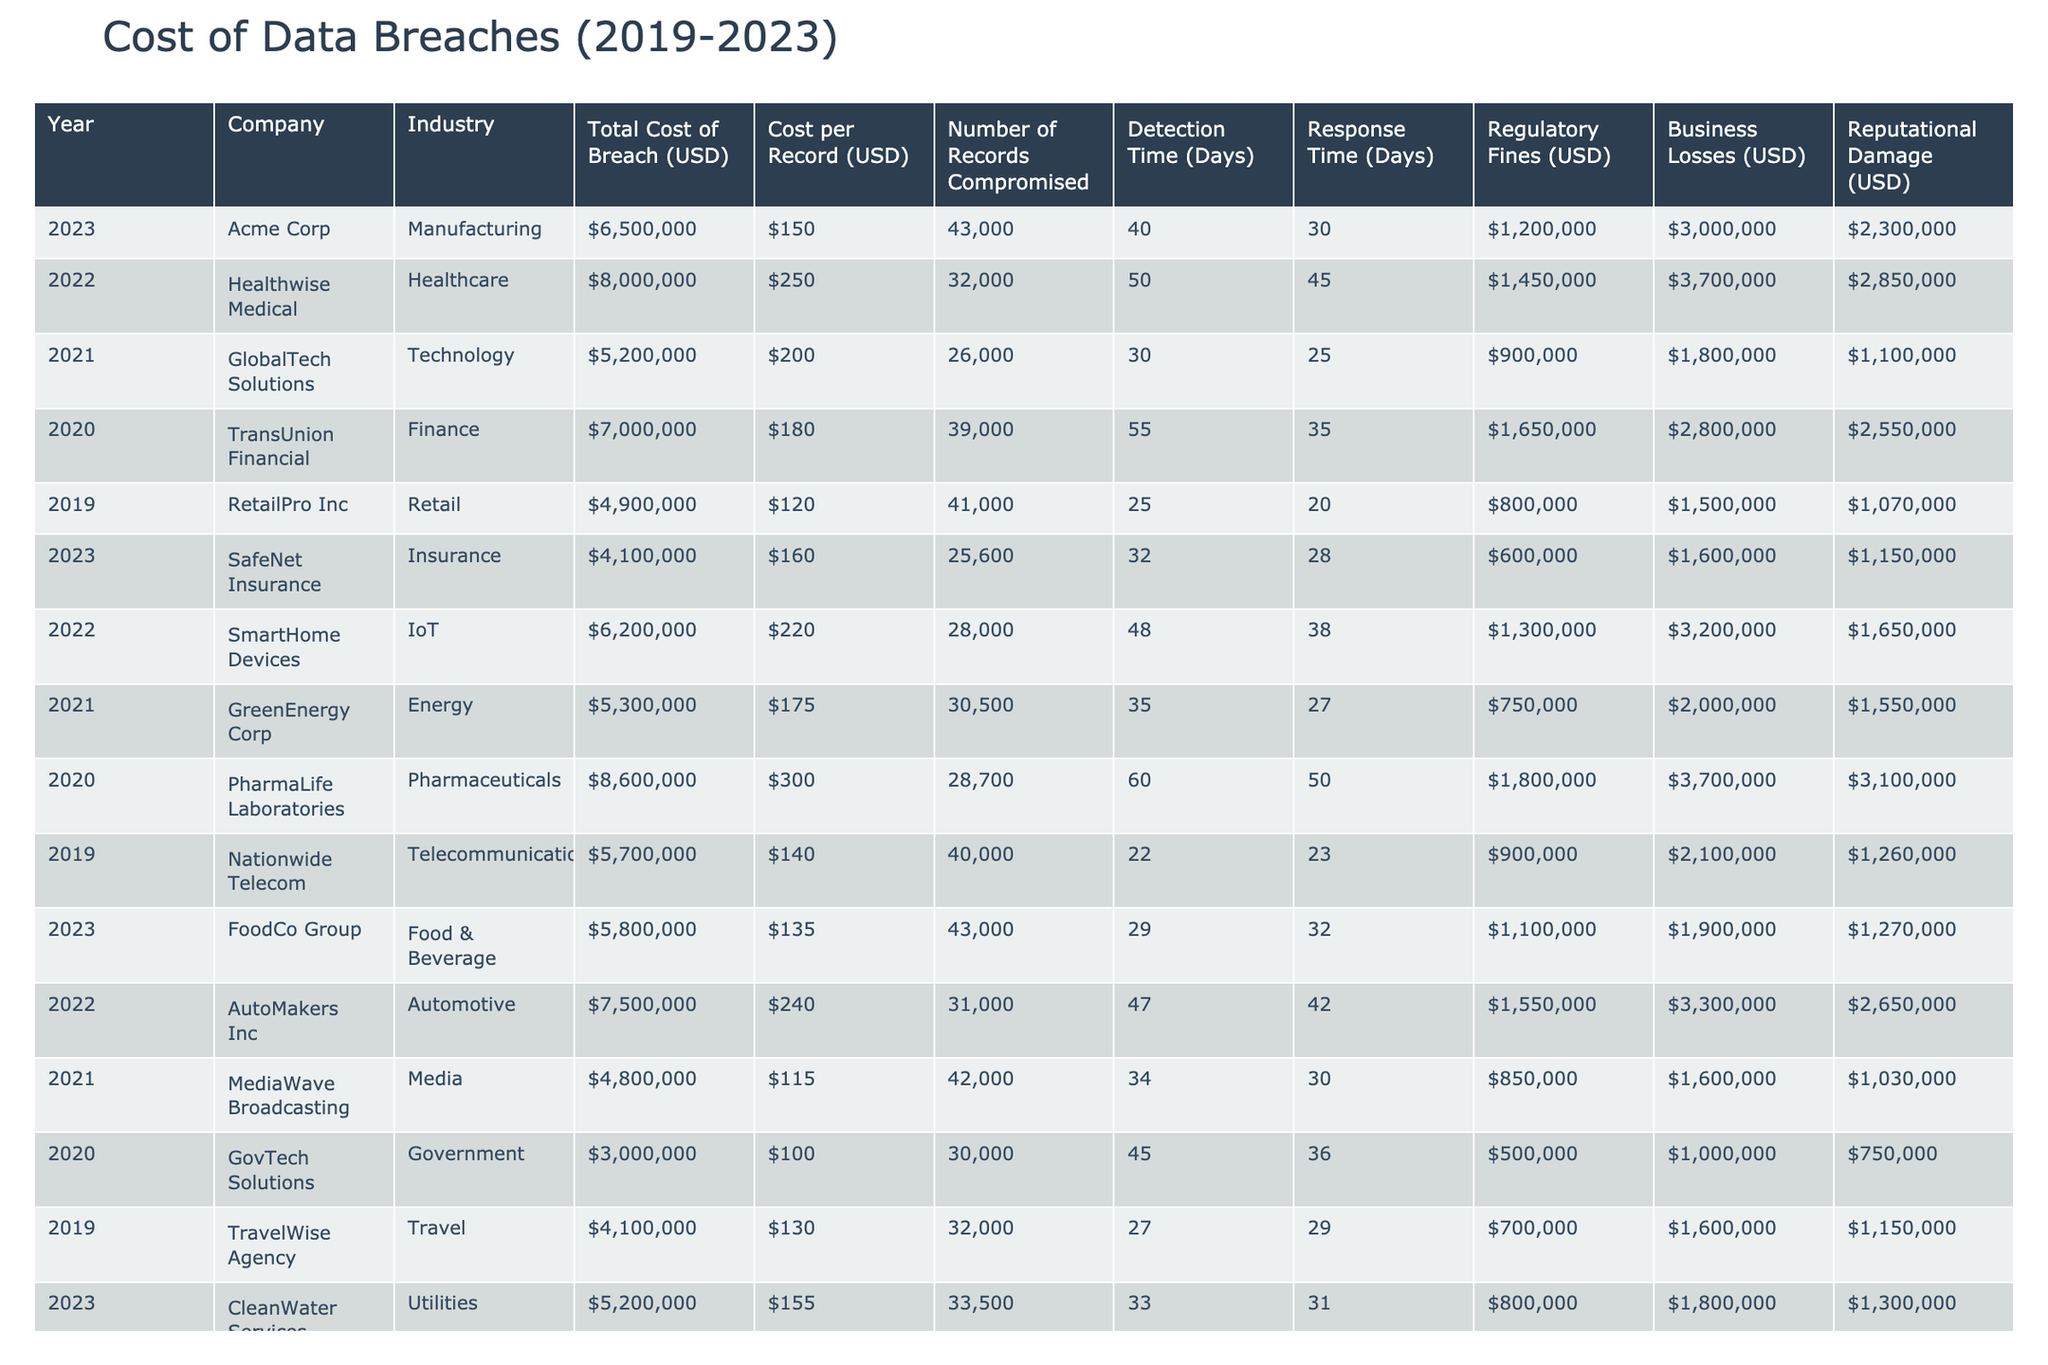What was the total cost of the data breach for Healthwise Medical in 2022? According to the table, the total cost of the data breach for Healthwise Medical in 2022 is listed as $8,000,000.
Answer: $8,000,000 Which industry had the highest total cost of breach in 2020? By examining the table, the Pharmaceuticals industry (PharmaLife Laboratories) had the highest total cost of breach at $8,600,000 in 2020.
Answer: Pharmaceuticals What is the average cost per record for the breaches that occurred in 2023? For the year 2023, the cost per record values are $150 (Acme Corp) and $160 (SafeNet Insurance). The average is calculated as (150 + 160) / 2 = 155.
Answer: $155 Did any company suffer a breach with regulatory fines exceeding $1,500,000 in 2022? Checking the table for 2022, both Healthwise Medical ($1,450,000) and AutoMakers Inc ($1,550,000) have regulatory fines; however, only AutoMakers Inc exceeded $1,500,000.
Answer: Yes What was the total business loss from cyberattacks in 2021 across all companies? In 2021, the business losses are $1,800,000 (GlobalTech Solutions), $2,000,000 (GreenEnergy Corp), and $1,600,000 (MediaWave Broadcasting), summing them gives a total of $1,800,000 + $2,000,000 + $1,600,000 = $5,400,000.
Answer: $5,400,000 Which company faced the longest detection time in 2020? The table shows that PharmaLife Laboratories had a detection time of 60 days in 2020, which is the longest compared to other companies in that year.
Answer: PharmaLife Laboratories What is the difference in total cost of breach between 2022 and 2021? The total cost of breaches was $8,000,000 in 2022 (Healthwise Medical) and $5,200,000 in 2021 (GlobalTech Solutions). The difference is calculated as $8,000,000 - $5,200,000 = $2,800,000.
Answer: $2,800,000 Which industry had the lowest regulatory fines in 2020? In 2020, the Government industry (GovTech Solutions) had regulatory fines of $500,000, which is lower than other industries listed for that year.
Answer: Government What was the total reputational damage incurred by companies in the Retail and Technology industries? For the Retail industry (RetailPro Inc) the reputational damage was $1,070,000, and for the Technology industry (GlobalTech Solutions), it was $1,100,000. The total reputational damage is $1,070,000 + $1,100,000 = $2,170,000.
Answer: $2,170,000 In which year did the Food & Beverage industry face a breach and what was its total cost? The Food & Beverage industry (FoodCo Group) faced a breach in 2023, with a total cost of $5,800,000.
Answer: 2023, $5,800,000 